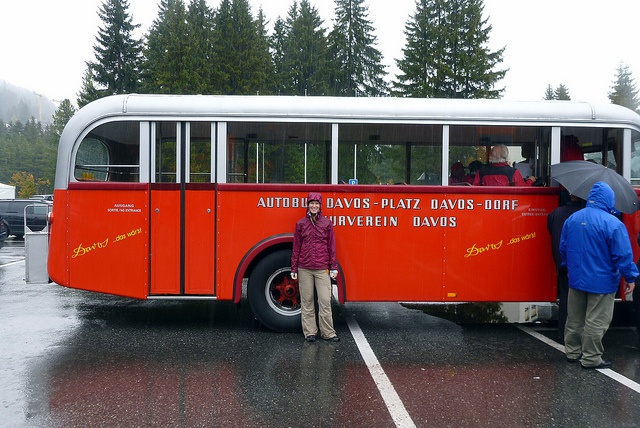Describe the objects in this image and their specific colors. I can see bus in white, red, black, and brown tones, people in white, darkblue, gray, black, and navy tones, people in white, purple, darkgray, and gray tones, umbrella in white, gray, and darkblue tones, and people in white, black, maroon, navy, and gray tones in this image. 